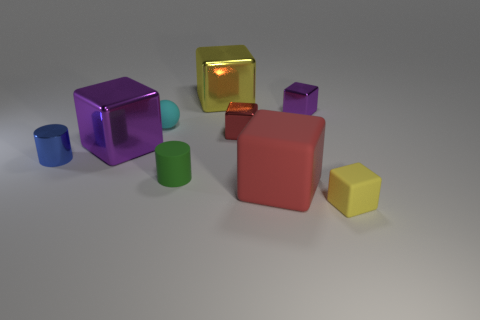Do the small green cylinder and the yellow object behind the tiny green cylinder have the same material?
Your answer should be very brief. No. What is the material of the tiny blue thing that is the same shape as the tiny green rubber object?
Make the answer very short. Metal. Are there more small blue metallic cylinders that are to the left of the yellow metallic block than big red matte cubes behind the tiny purple block?
Keep it short and to the point. Yes. What shape is the other big object that is made of the same material as the big yellow thing?
Your answer should be compact. Cube. What number of other things are the same shape as the large rubber thing?
Give a very brief answer. 5. The yellow object that is to the right of the tiny red shiny object has what shape?
Make the answer very short. Cube. The small metal cylinder has what color?
Your answer should be compact. Blue. What number of other things are there of the same size as the red shiny cube?
Ensure brevity in your answer.  5. There is a tiny cylinder behind the cylinder in front of the small metallic cylinder; what is it made of?
Your answer should be compact. Metal. Is the size of the yellow rubber cube the same as the purple shiny thing on the right side of the big matte object?
Make the answer very short. Yes. 